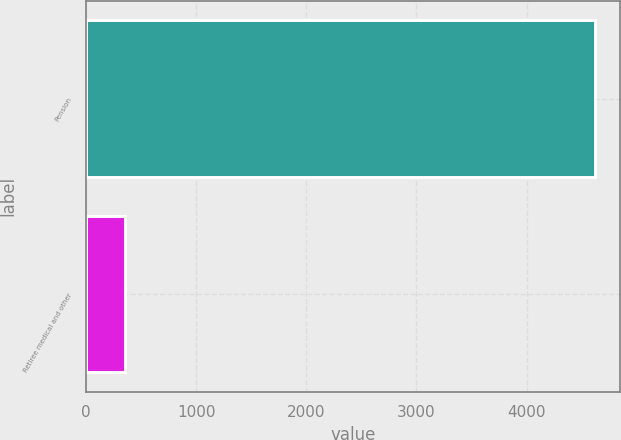<chart> <loc_0><loc_0><loc_500><loc_500><bar_chart><fcel>Pension<fcel>Retiree medical and other<nl><fcel>4621<fcel>353<nl></chart> 